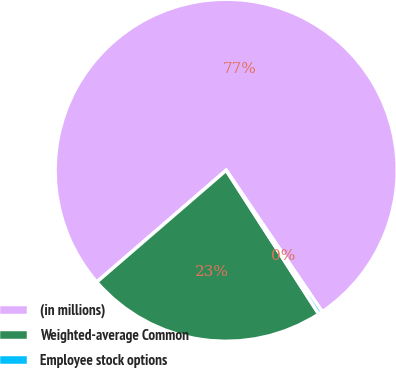Convert chart to OTSL. <chart><loc_0><loc_0><loc_500><loc_500><pie_chart><fcel>(in millions)<fcel>Weighted-average Common<fcel>Employee stock options<nl><fcel>76.85%<fcel>22.77%<fcel>0.38%<nl></chart> 